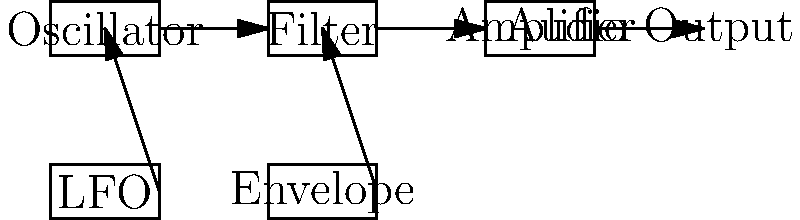In this block diagram of a basic synthesizer, which component is responsible for shaping the overall volume contour of a sound over time, crucial for creating dynamic and evolving textures in electronic dance music? To answer this question, let's break down the components of the synthesizer block diagram:

1. Oscillator: Generates the initial waveform (e.g., sine, square, sawtooth).
2. Filter: Modifies the harmonic content of the sound.
3. Amplifier: Controls the overall volume of the sound.
4. LFO (Low-Frequency Oscillator): Provides cyclic modulation to various parameters.
5. Envelope: Shapes the sound's characteristics over time.

The component responsible for shaping the overall volume contour of a sound over time is the Envelope. In synthesizer terminology, this is often referred to as the ADSR envelope (Attack, Decay, Sustain, Release).

The Envelope controls how the sound evolves from the moment a key is pressed to when it's released:
- Attack: How quickly the sound reaches its initial peak volume
- Decay: How quickly the sound falls to the sustain level
- Sustain: The volume level maintained while the key is held
- Release: How quickly the sound fades out after the key is released

This envelope shaping is crucial for creating dynamic and evolving textures in electronic dance music, as it allows for the creation of punchy basses, swelling pads, or percussive plucks, all of which are common in genres like trance that Armin van Buuren is known for.

In the diagram, we can see that the Envelope is connected to the Amplifier, indicating its role in controlling the volume over time.
Answer: Envelope 